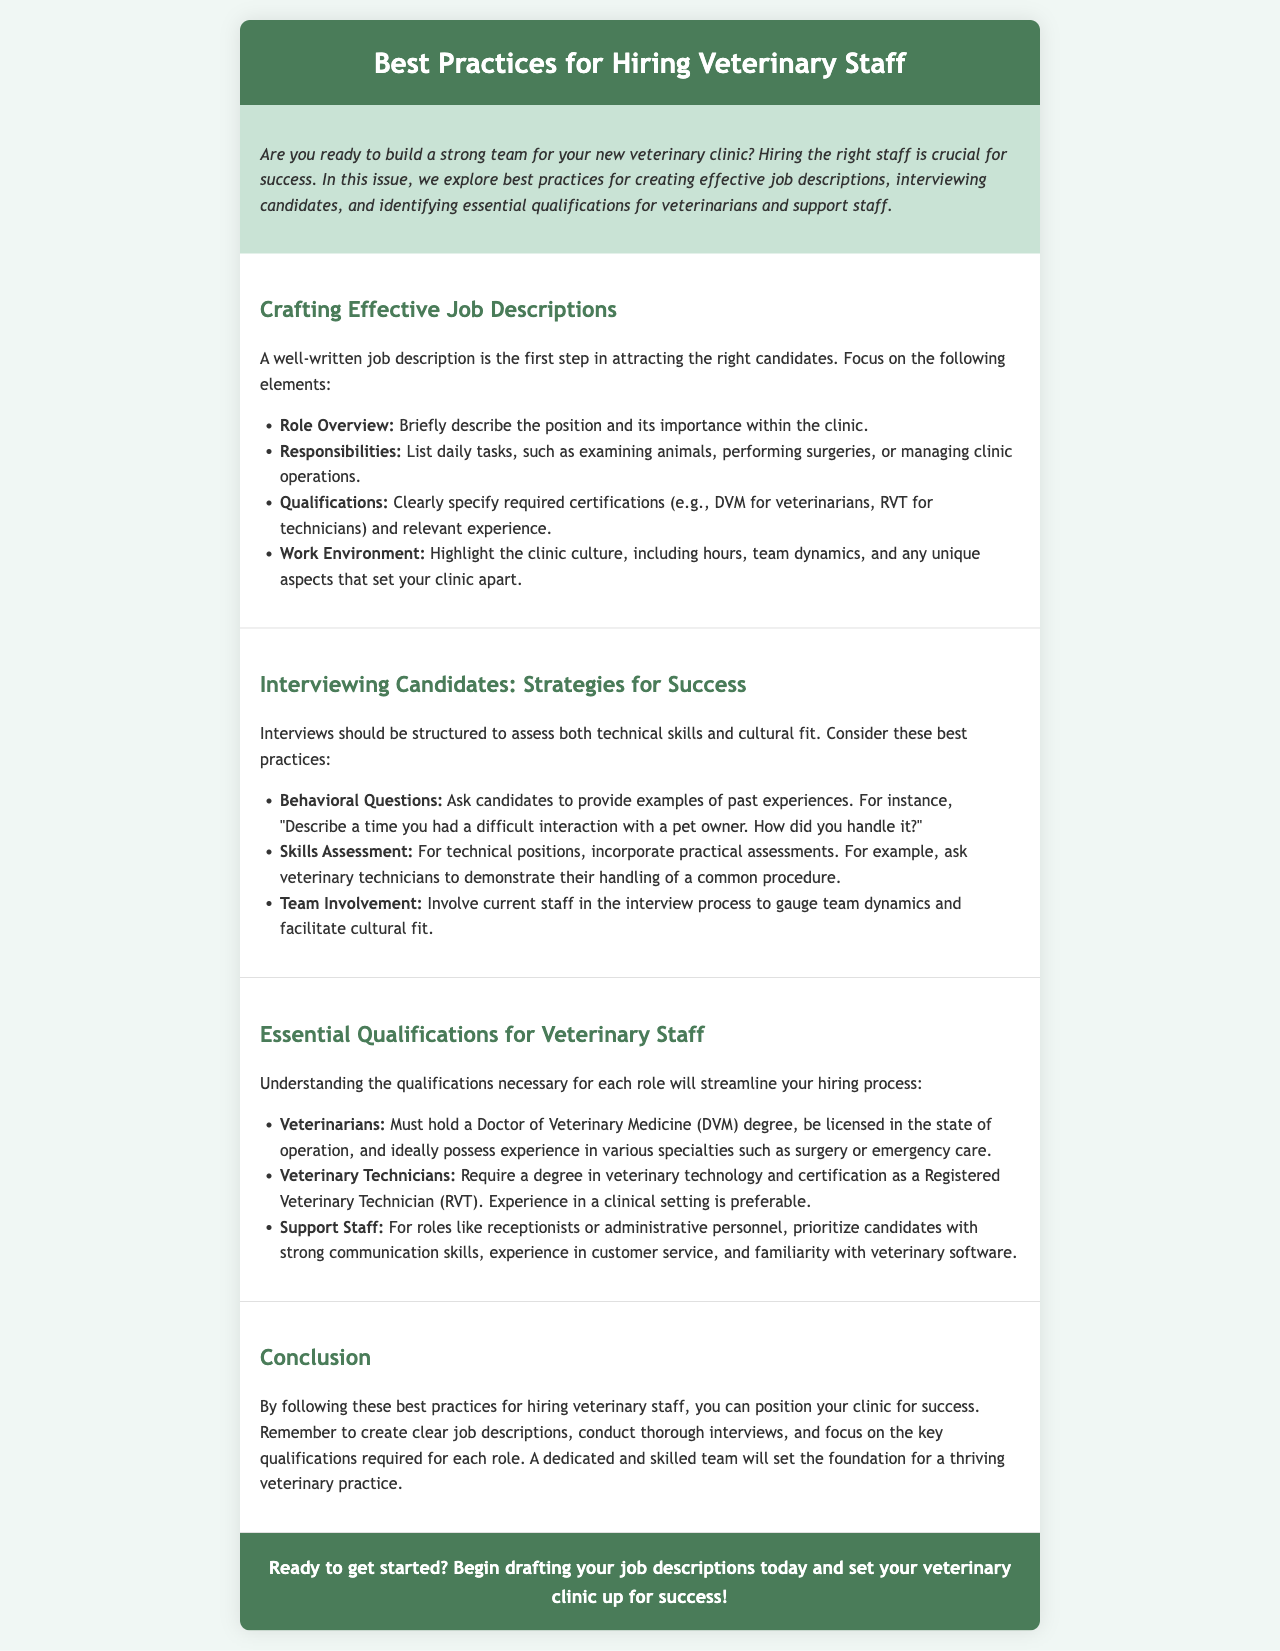What is the focus of the newsletter? The newsletter focuses on hiring practices for veterinary staff, including job descriptions, interviewing, and qualifications.
Answer: hiring practices for veterinary staff What type of degree is required for veterinarians? The document specifies that veterinarians must hold a Doctor of Veterinary Medicine (DVM) degree.
Answer: Doctor of Veterinary Medicine (DVM) What is one method suggested for interviewing candidates? The newsletter recommends using behavioral questions to assess candidates' past experiences.
Answer: behavioral questions Who should be prioritized for support staff roles? For support staff roles, candidates with strong communication skills and customer service experience should be prioritized.
Answer: strong communication skills and customer service experience What do effective job descriptions include? Effective job descriptions should include role overview, responsibilities, qualifications, and work environment.
Answer: role overview, responsibilities, qualifications, work environment 